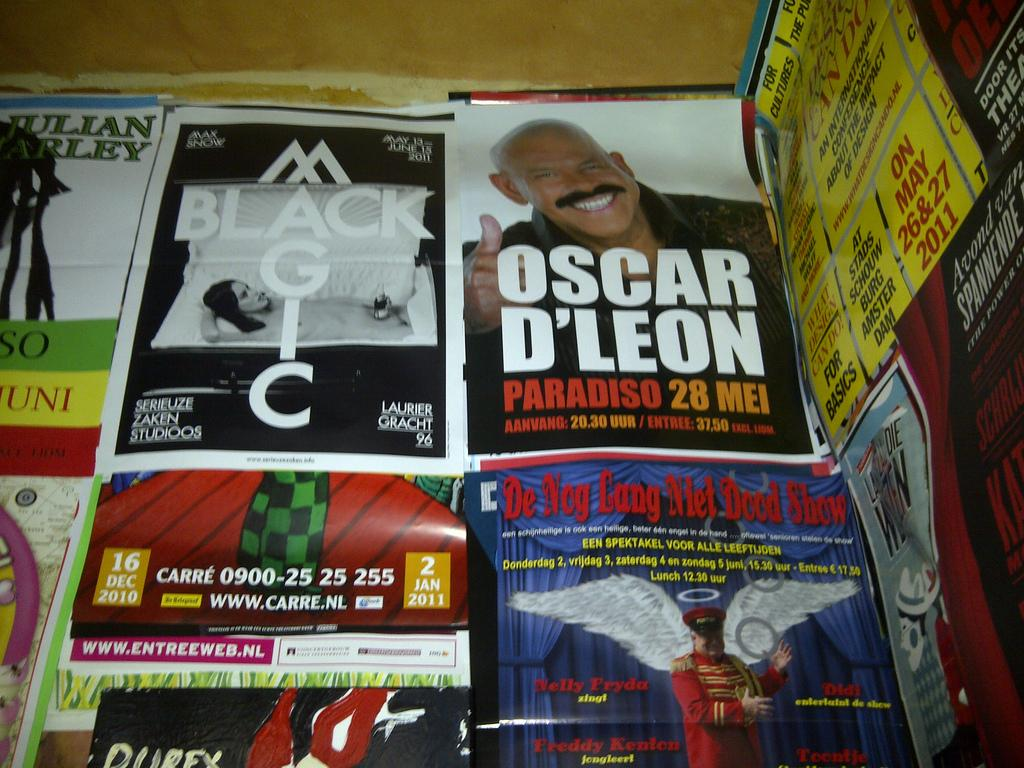<image>
Share a concise interpretation of the image provided. Posters for several different shows overlap one another, including Black Magic. 